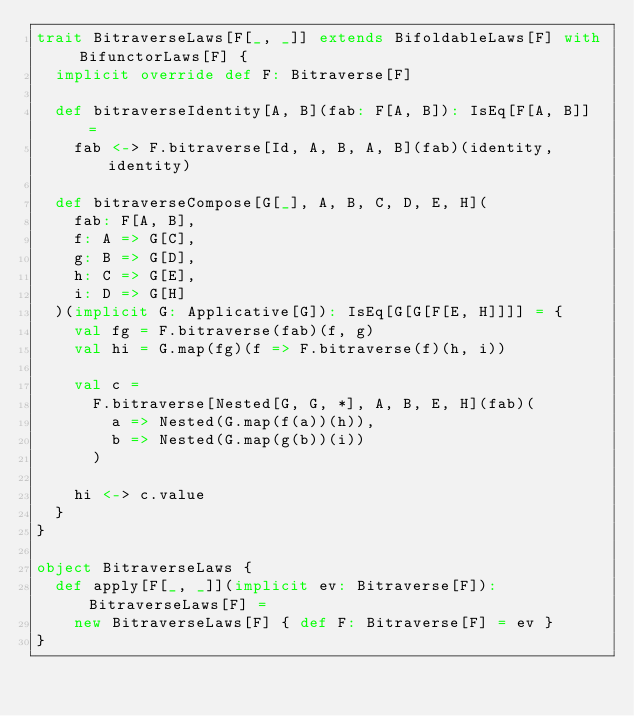<code> <loc_0><loc_0><loc_500><loc_500><_Scala_>trait BitraverseLaws[F[_, _]] extends BifoldableLaws[F] with BifunctorLaws[F] {
  implicit override def F: Bitraverse[F]

  def bitraverseIdentity[A, B](fab: F[A, B]): IsEq[F[A, B]] =
    fab <-> F.bitraverse[Id, A, B, A, B](fab)(identity, identity)

  def bitraverseCompose[G[_], A, B, C, D, E, H](
    fab: F[A, B],
    f: A => G[C],
    g: B => G[D],
    h: C => G[E],
    i: D => G[H]
  )(implicit G: Applicative[G]): IsEq[G[G[F[E, H]]]] = {
    val fg = F.bitraverse(fab)(f, g)
    val hi = G.map(fg)(f => F.bitraverse(f)(h, i))

    val c =
      F.bitraverse[Nested[G, G, *], A, B, E, H](fab)(
        a => Nested(G.map(f(a))(h)),
        b => Nested(G.map(g(b))(i))
      )

    hi <-> c.value
  }
}

object BitraverseLaws {
  def apply[F[_, _]](implicit ev: Bitraverse[F]): BitraverseLaws[F] =
    new BitraverseLaws[F] { def F: Bitraverse[F] = ev }
}
</code> 